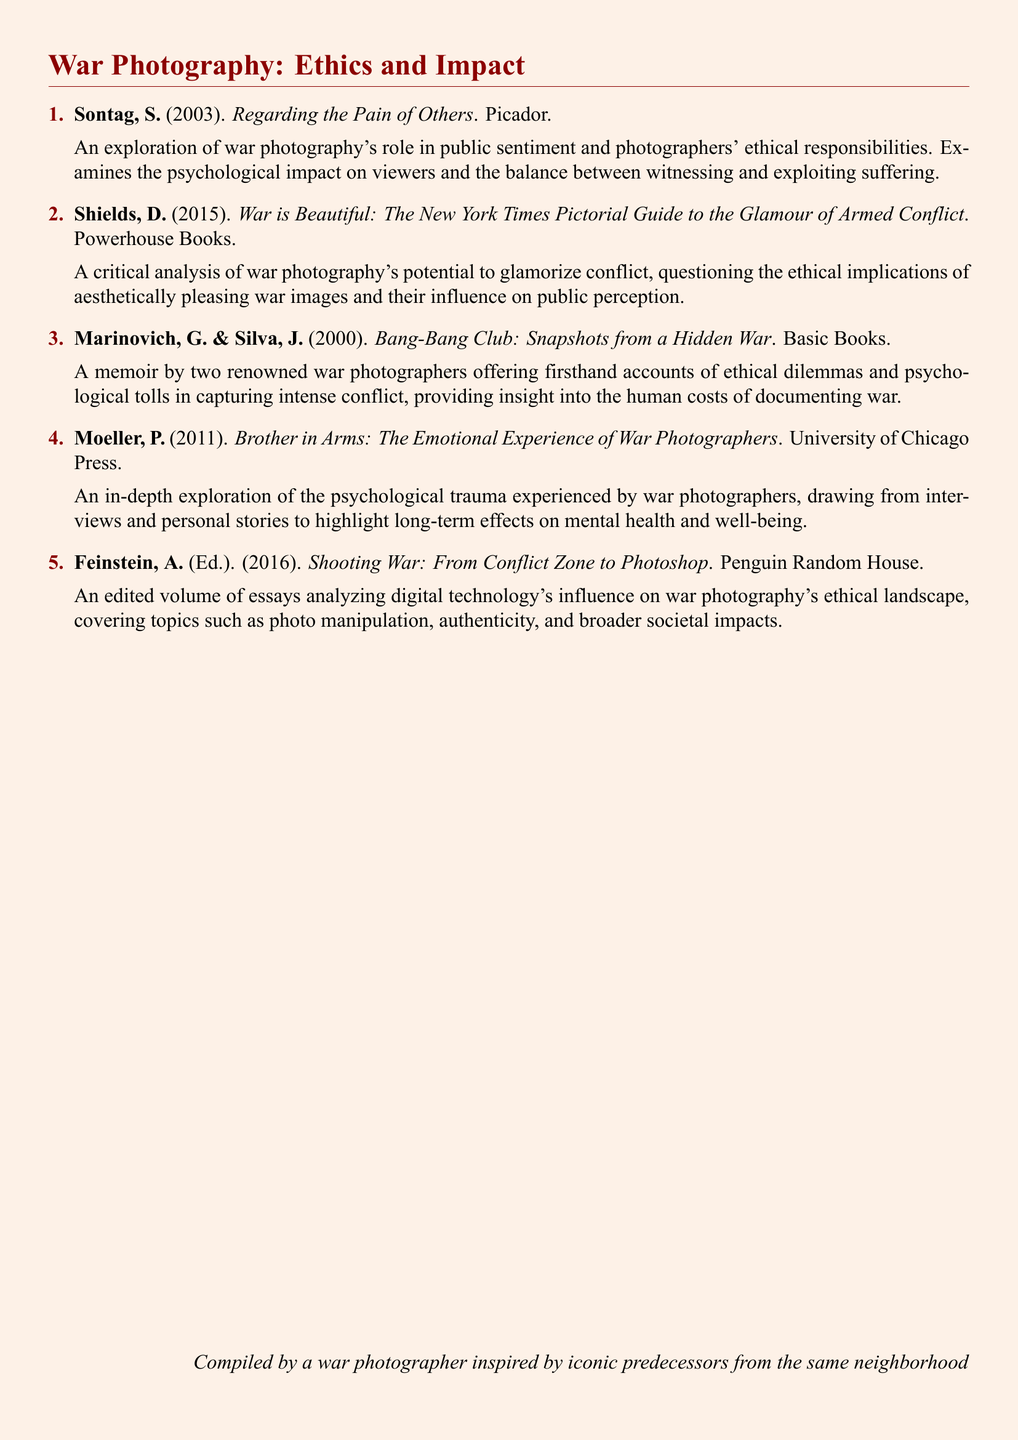What is the title of Sontag's work? The title of Sontag's work is specified in the document, which is "Regarding the Pain of Others."
Answer: Regarding the Pain of Others Who are the authors of "Bang-Bang Club"? The authors of "Bang-Bang Club" are mentioned in the document as Marinovich and Silva.
Answer: Marinovich, Silva What year was "War is Beautiful" published? The publication year is indicated in the document as 2015 for "War is Beautiful."
Answer: 2015 Which publisher released "Brother in Arms"? The document lists the publisher of "Brother in Arms" as University of Chicago Press.
Answer: University of Chicago Press How many items are listed in the bibliography? The document shows a total count of items in the bibliography, which is five.
Answer: Five What is a central theme discussed in "Shooting War"? The theme discussed in "Shooting War" includes the ethical implications of digital technology in war photography.
Answer: Digital technology's ethical implications Which book focuses on the psychological experiences of war photographers? "Brother in Arms" specifically explores the emotional experiences of war photographers as stated in the document.
Answer: Brother in Arms What type of publication is mentioned for "Shooting War"? The document indicates that "Shooting War" is an edited volume of essays.
Answer: Edited volume of essays How does "War is Beautiful" challenge perceptions of war photography? "War is Beautiful" questions the ethical implications of aesthetically pleasing war images in conflict.
Answer: Ethical implications of aesthetically pleasing images 